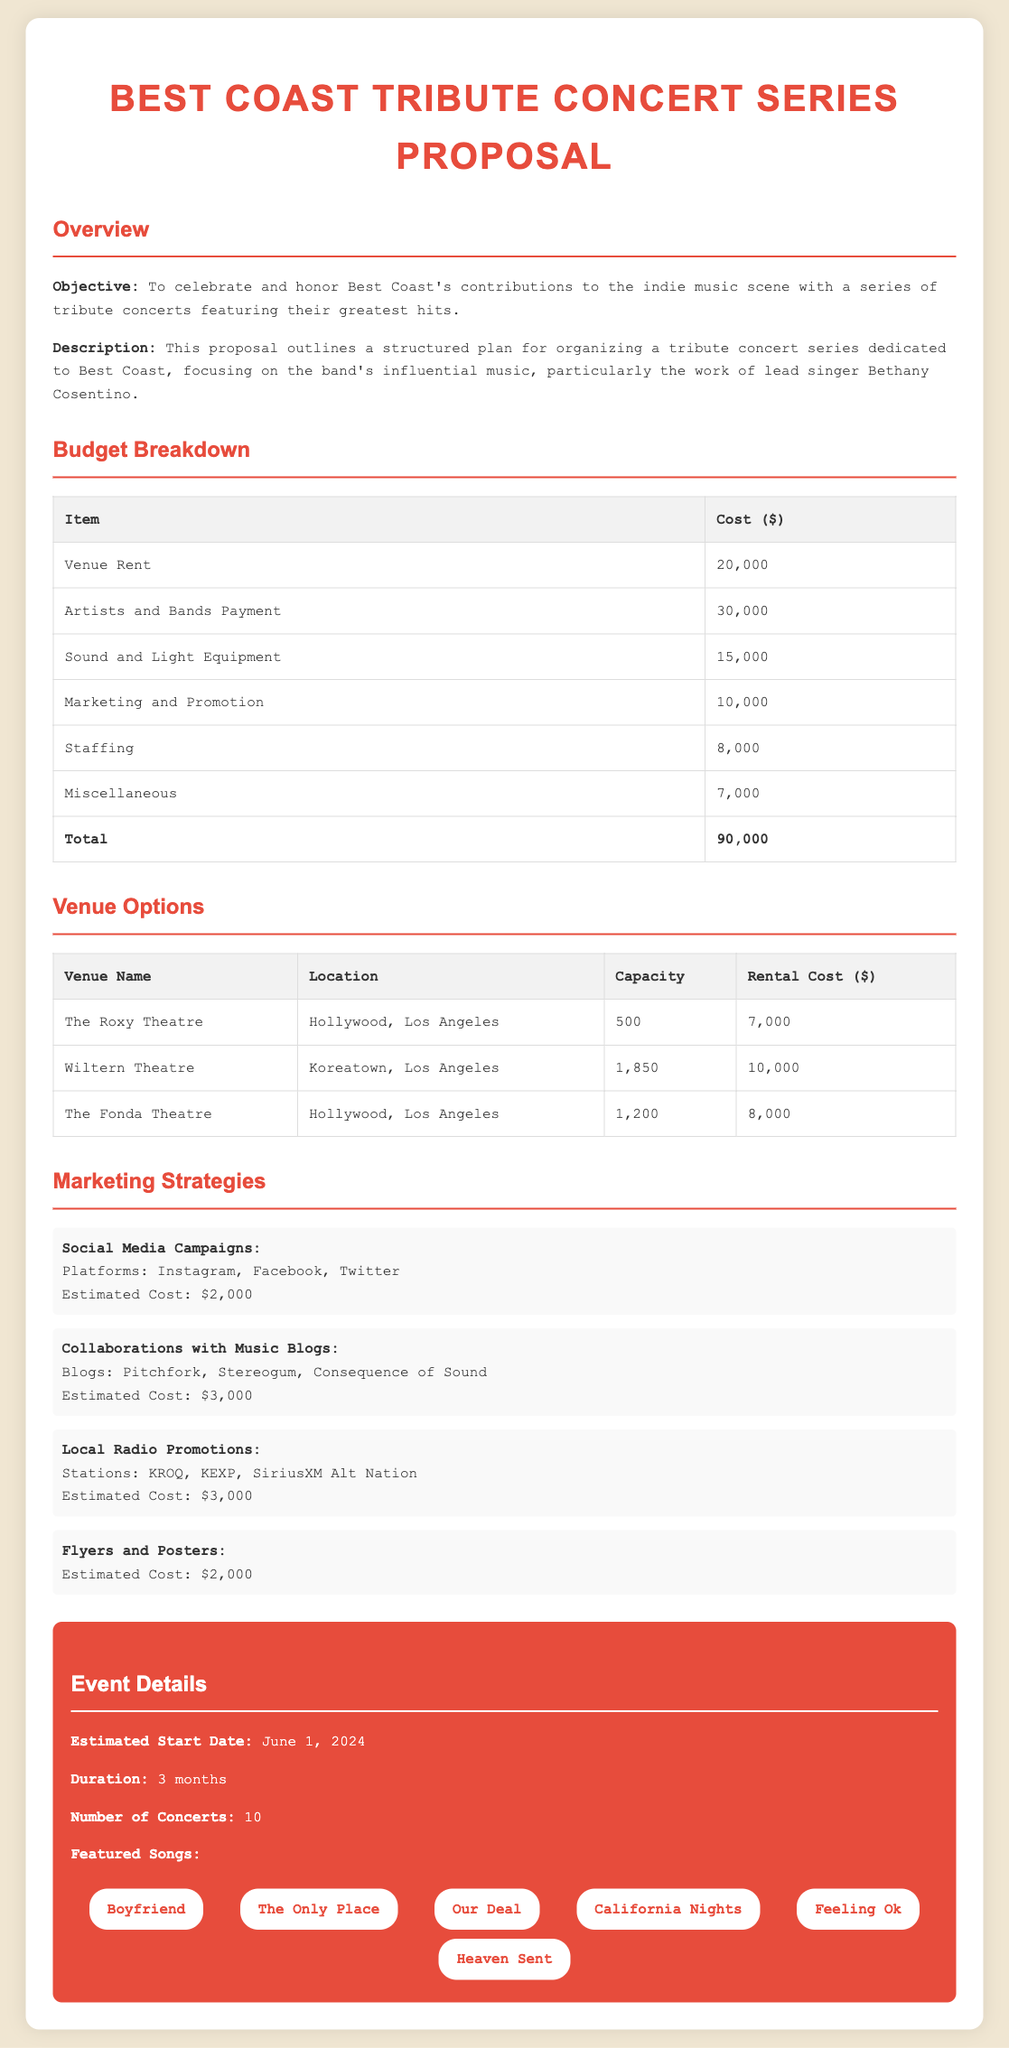what is the total budget for the concert series? The total budget is summarized in the Budget Breakdown section, which adds up to 90,000.
Answer: 90,000 how many concerts will be held during the series? The number of concerts is specified in the Event Details section, which states there will be 10 concerts.
Answer: 10 what is the venue with the highest capacity? The venue with the highest capacity is detailed in the Venue Options section, stating Wiltern Theatre has a capacity of 1,850.
Answer: Wiltern Theatre what is the estimated start date for the concert series? The estimated start date is mentioned in the Event Details section, which indicates June 1, 2024.
Answer: June 1, 2024 how much is allocated for marketing and promotion? The budget allocation for marketing and promotion is discussed in the Budget Breakdown section, which shows 10,000 set aside for this purpose.
Answer: 10,000 which song is listed as the first featured song? The first featured song is outlined in the Event Details' Featured Songs section, listing Boyfriend first.
Answer: Boyfriend how much does it cost to rent The Roxy Theatre? The rental cost for The Roxy Theatre is provided in the Venue Options section, which states it is 7,000.
Answer: 7,000 what is the estimated cost for social media campaigns? The cost for social media campaigns is indicated in the Marketing Strategies section, and it amounts to 2,000.
Answer: 2,000 what type of concert series is being proposed? The type of concert series being proposed is captured in the Overview section as a tribute to Best Coast.
Answer: Tribute concert series 